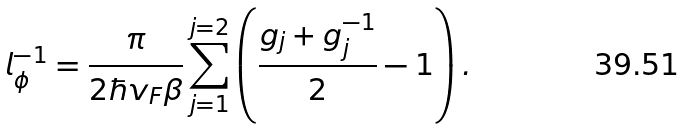Convert formula to latex. <formula><loc_0><loc_0><loc_500><loc_500>l _ { \phi } ^ { - 1 } = \frac { \pi } { 2 \hbar { v } _ { F } \beta } \sum _ { j = 1 } ^ { j = 2 } \left ( \frac { g _ { j } + g _ { j } ^ { - 1 } } { 2 } - 1 \right ) .</formula> 